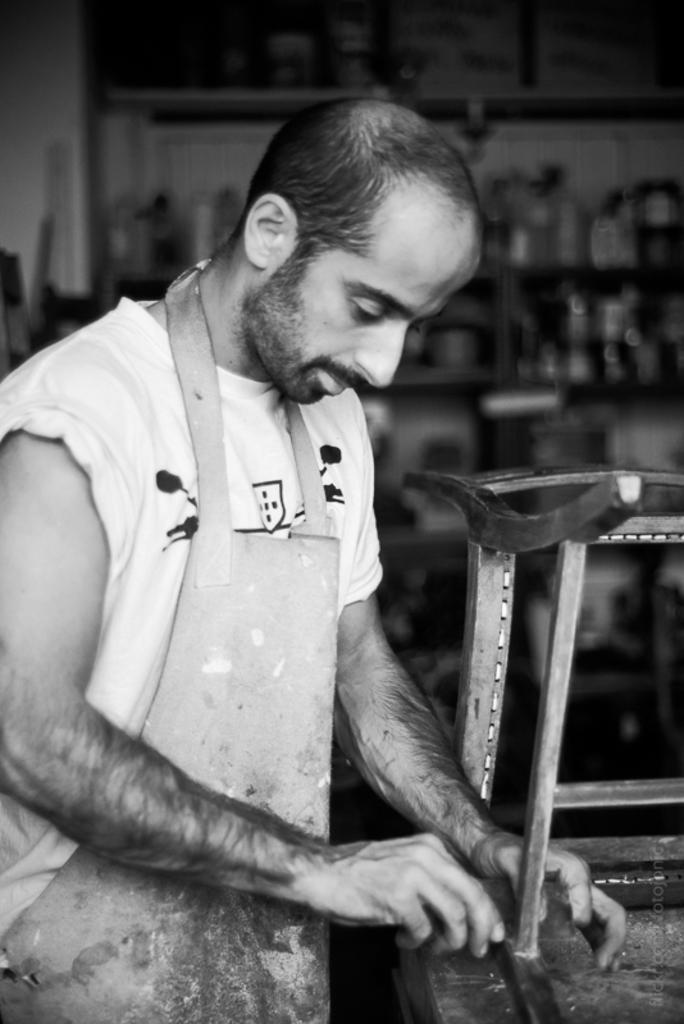What can be seen in the image? There is a person in the image. What is the person wearing? The person is wearing an apron. What is in front of the person? There is a wooden object in front of the person. What type of objects can be seen on racks in the image? There are objects on racks in the image, but the specific objects are not mentioned in the facts. How would you describe the background of the image? The background of the image is blurred. What type of alarm is going off in the image? There is no alarm present in the image. What type of army is visible in the image? There is no army present in the image. 